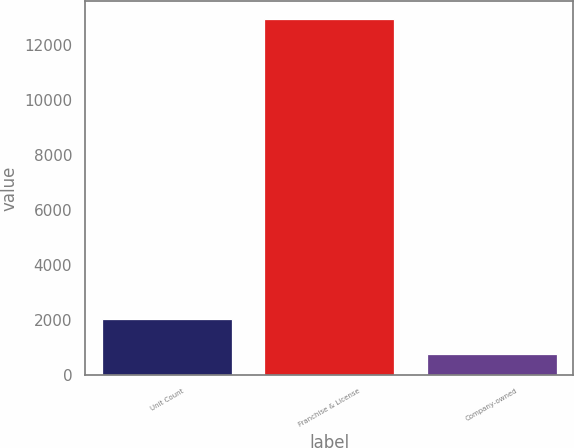Convert chart to OTSL. <chart><loc_0><loc_0><loc_500><loc_500><bar_chart><fcel>Unit Count<fcel>Franchise & License<fcel>Company-owned<nl><fcel>2015<fcel>12969<fcel>759<nl></chart> 